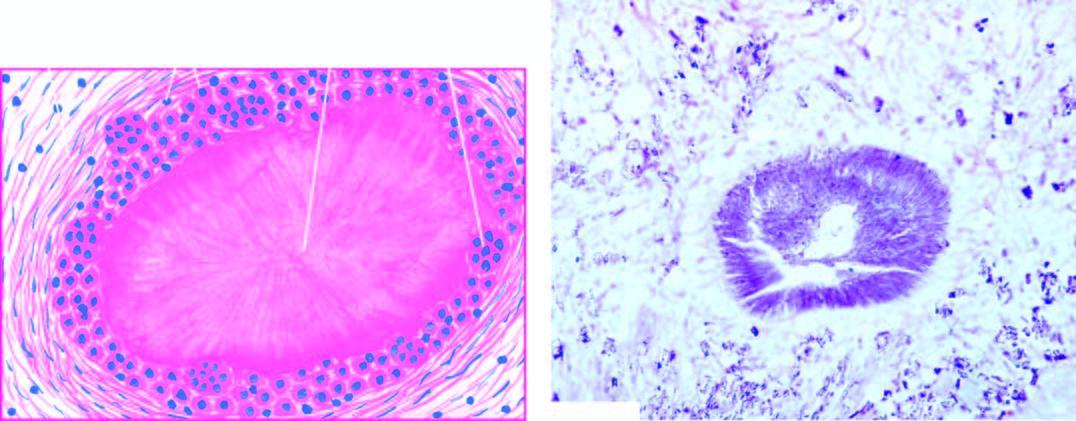what is gouty tophus, showing central aggregates of urate crystals surrounded by?
Answer the question using a single word or phrase. Inflammatory cells 